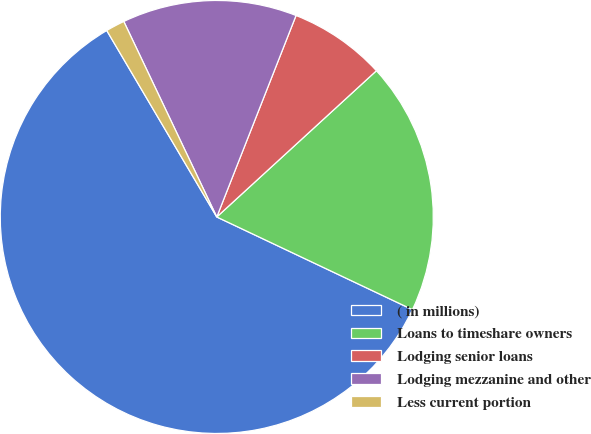Convert chart. <chart><loc_0><loc_0><loc_500><loc_500><pie_chart><fcel>( in millions)<fcel>Loans to timeshare owners<fcel>Lodging senior loans<fcel>Lodging mezzanine and other<fcel>Less current portion<nl><fcel>59.47%<fcel>18.84%<fcel>7.23%<fcel>13.03%<fcel>1.42%<nl></chart> 